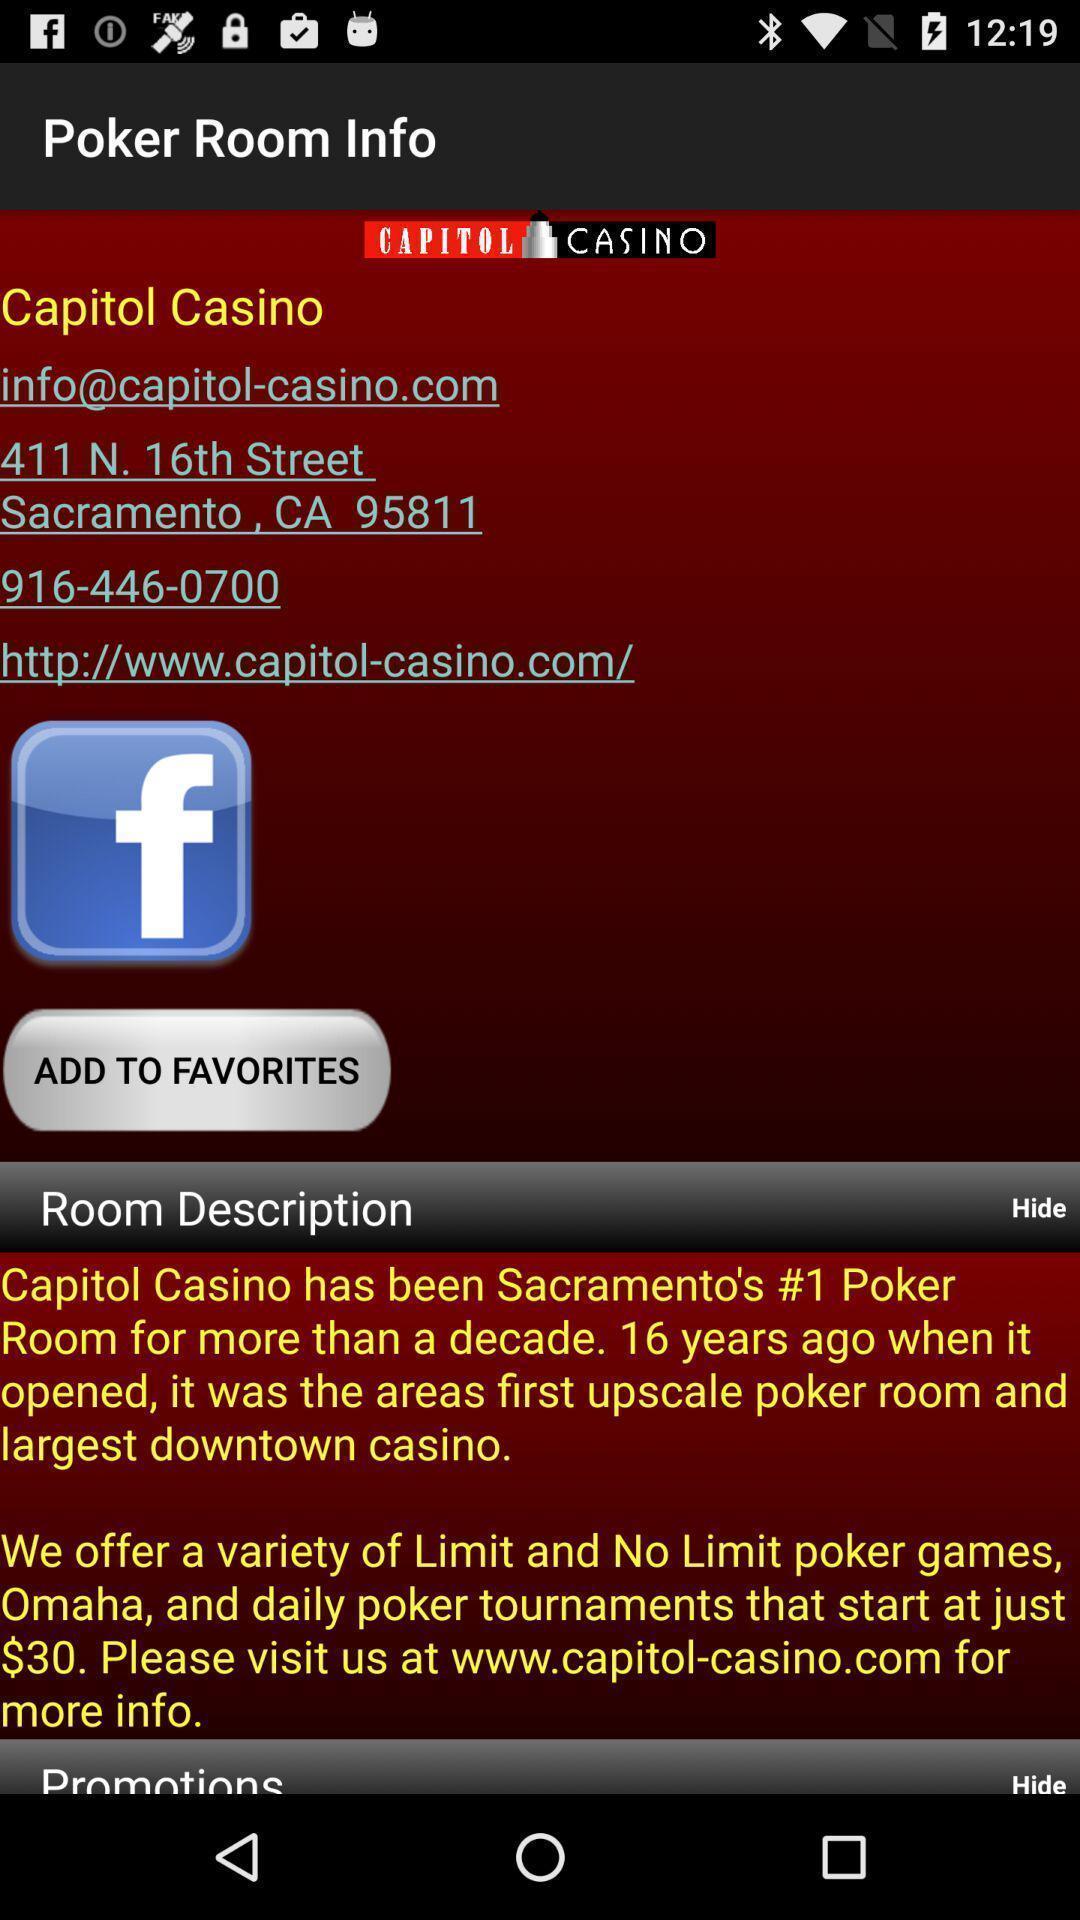Summarize the main components in this picture. Various info displayed of a online gaming app. 